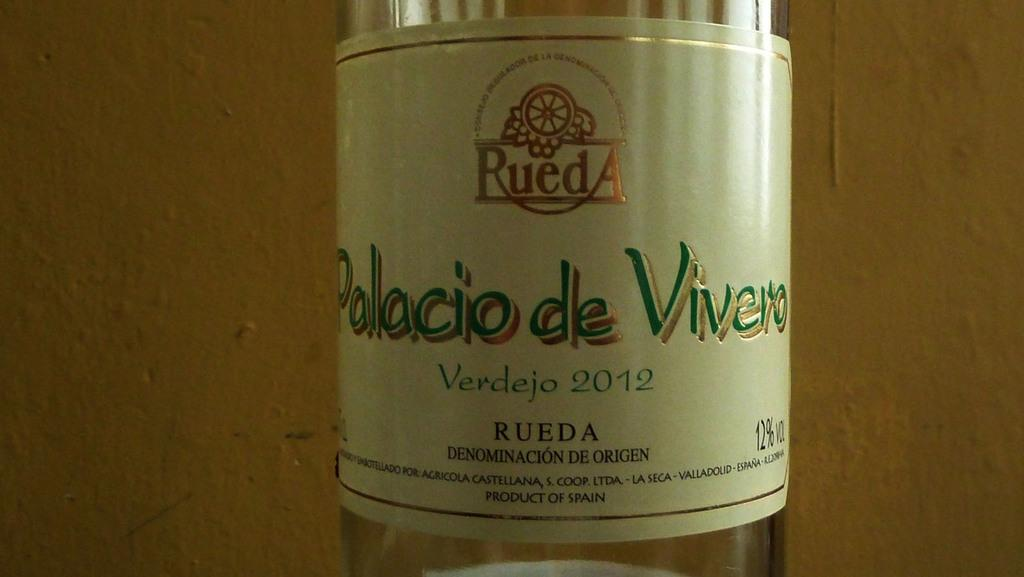<image>
Share a concise interpretation of the image provided. the word palacio that is on a wine bottle 